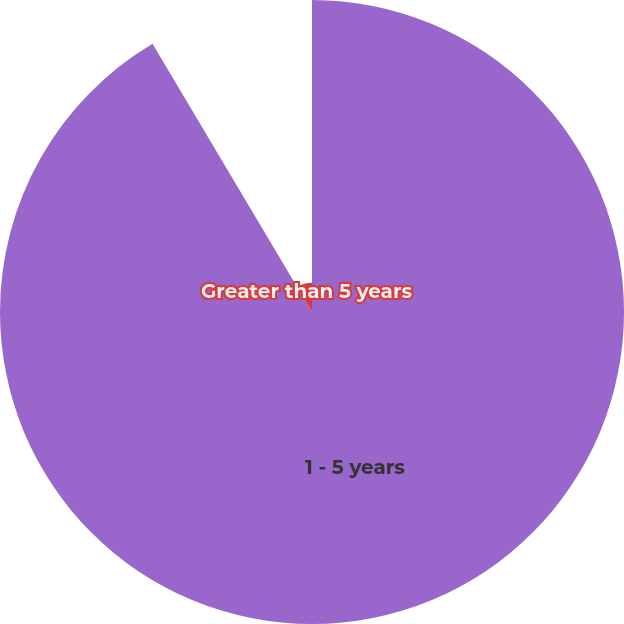Convert chart to OTSL. <chart><loc_0><loc_0><loc_500><loc_500><pie_chart><fcel>1 - 5 years<fcel>Greater than 5 years<nl><fcel>91.46%<fcel>8.54%<nl></chart> 